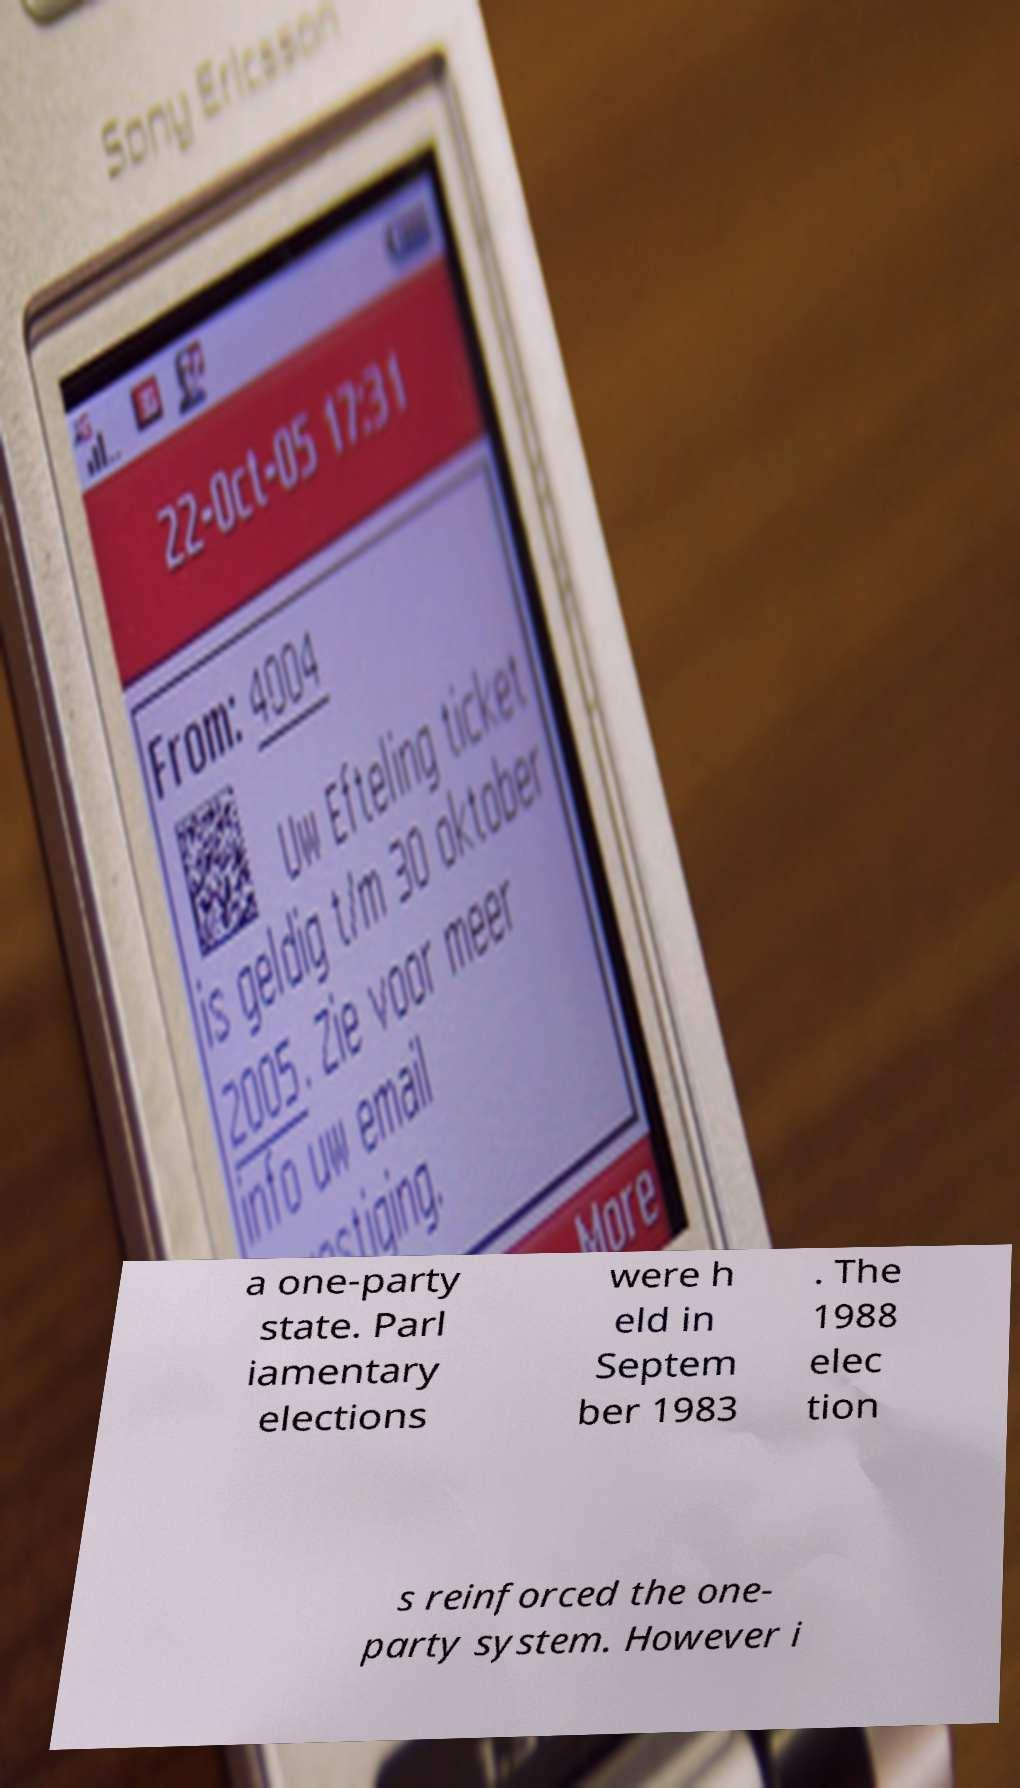What messages or text are displayed in this image? I need them in a readable, typed format. a one-party state. Parl iamentary elections were h eld in Septem ber 1983 . The 1988 elec tion s reinforced the one- party system. However i 